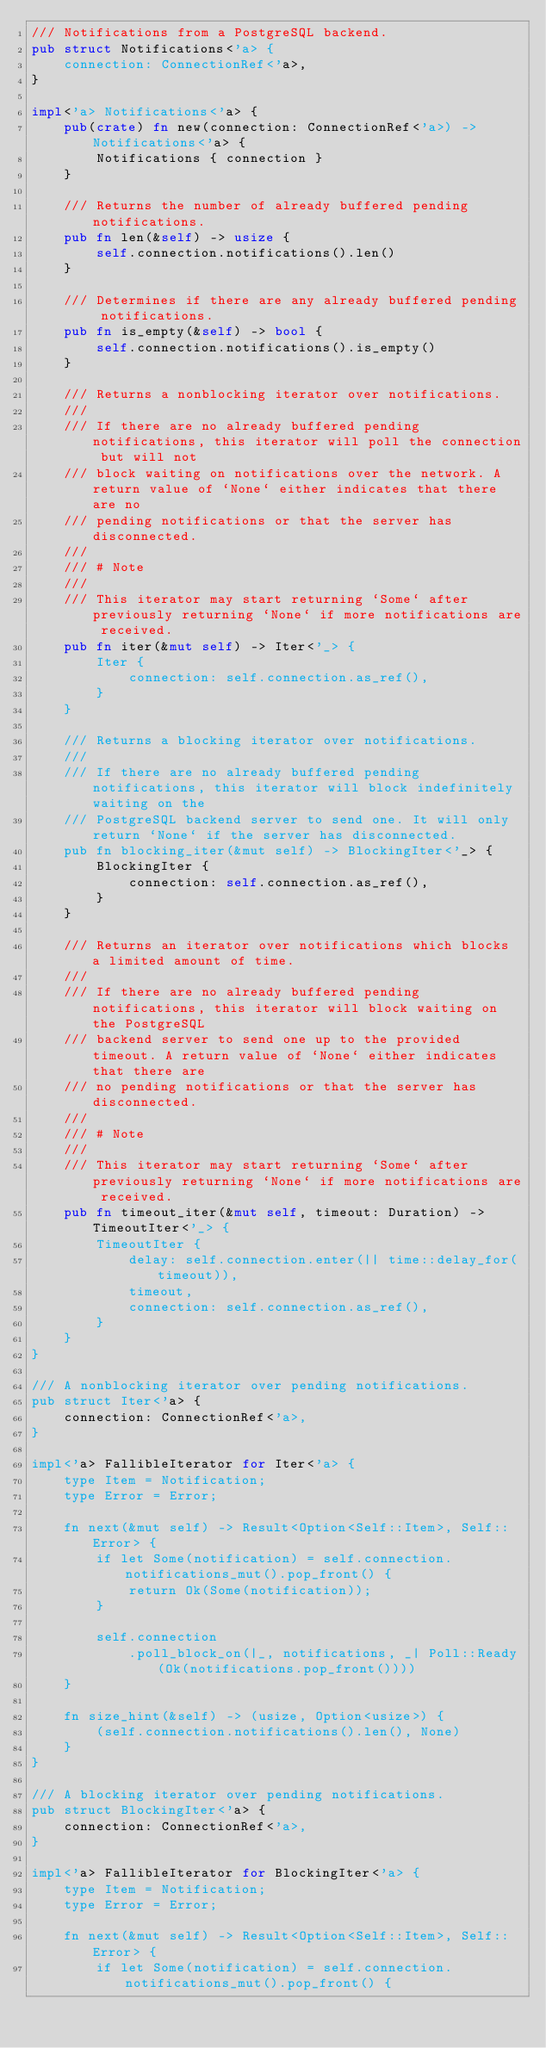<code> <loc_0><loc_0><loc_500><loc_500><_Rust_>/// Notifications from a PostgreSQL backend.
pub struct Notifications<'a> {
    connection: ConnectionRef<'a>,
}

impl<'a> Notifications<'a> {
    pub(crate) fn new(connection: ConnectionRef<'a>) -> Notifications<'a> {
        Notifications { connection }
    }

    /// Returns the number of already buffered pending notifications.
    pub fn len(&self) -> usize {
        self.connection.notifications().len()
    }

    /// Determines if there are any already buffered pending notifications.
    pub fn is_empty(&self) -> bool {
        self.connection.notifications().is_empty()
    }

    /// Returns a nonblocking iterator over notifications.
    ///
    /// If there are no already buffered pending notifications, this iterator will poll the connection but will not
    /// block waiting on notifications over the network. A return value of `None` either indicates that there are no
    /// pending notifications or that the server has disconnected.
    ///
    /// # Note
    ///
    /// This iterator may start returning `Some` after previously returning `None` if more notifications are received.
    pub fn iter(&mut self) -> Iter<'_> {
        Iter {
            connection: self.connection.as_ref(),
        }
    }

    /// Returns a blocking iterator over notifications.
    ///
    /// If there are no already buffered pending notifications, this iterator will block indefinitely waiting on the
    /// PostgreSQL backend server to send one. It will only return `None` if the server has disconnected.
    pub fn blocking_iter(&mut self) -> BlockingIter<'_> {
        BlockingIter {
            connection: self.connection.as_ref(),
        }
    }

    /// Returns an iterator over notifications which blocks a limited amount of time.
    ///
    /// If there are no already buffered pending notifications, this iterator will block waiting on the PostgreSQL
    /// backend server to send one up to the provided timeout. A return value of `None` either indicates that there are
    /// no pending notifications or that the server has disconnected.
    ///
    /// # Note
    ///
    /// This iterator may start returning `Some` after previously returning `None` if more notifications are received.
    pub fn timeout_iter(&mut self, timeout: Duration) -> TimeoutIter<'_> {
        TimeoutIter {
            delay: self.connection.enter(|| time::delay_for(timeout)),
            timeout,
            connection: self.connection.as_ref(),
        }
    }
}

/// A nonblocking iterator over pending notifications.
pub struct Iter<'a> {
    connection: ConnectionRef<'a>,
}

impl<'a> FallibleIterator for Iter<'a> {
    type Item = Notification;
    type Error = Error;

    fn next(&mut self) -> Result<Option<Self::Item>, Self::Error> {
        if let Some(notification) = self.connection.notifications_mut().pop_front() {
            return Ok(Some(notification));
        }

        self.connection
            .poll_block_on(|_, notifications, _| Poll::Ready(Ok(notifications.pop_front())))
    }

    fn size_hint(&self) -> (usize, Option<usize>) {
        (self.connection.notifications().len(), None)
    }
}

/// A blocking iterator over pending notifications.
pub struct BlockingIter<'a> {
    connection: ConnectionRef<'a>,
}

impl<'a> FallibleIterator for BlockingIter<'a> {
    type Item = Notification;
    type Error = Error;

    fn next(&mut self) -> Result<Option<Self::Item>, Self::Error> {
        if let Some(notification) = self.connection.notifications_mut().pop_front() {</code> 